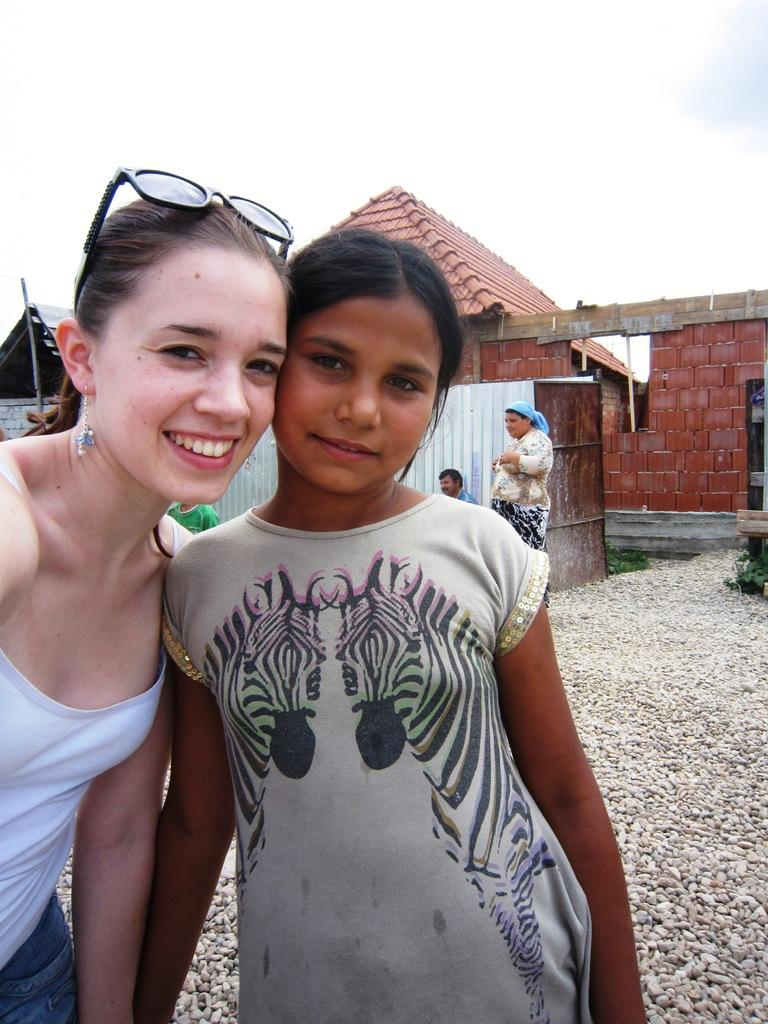Who or what can be seen in the image? There are people in the image. What type of natural elements are present in the image? There are stones and grass in the image. What type of structures can be seen in the image? There are houses and a wall in the image. What is visible in the background of the image? The sky is visible in the background of the image. What type of sign can be seen on the wall in the image? There is no sign present on the wall in the image. Can you tell me how many worms are crawling on the grass in the image? There are no worms visible on the grass in the image. 